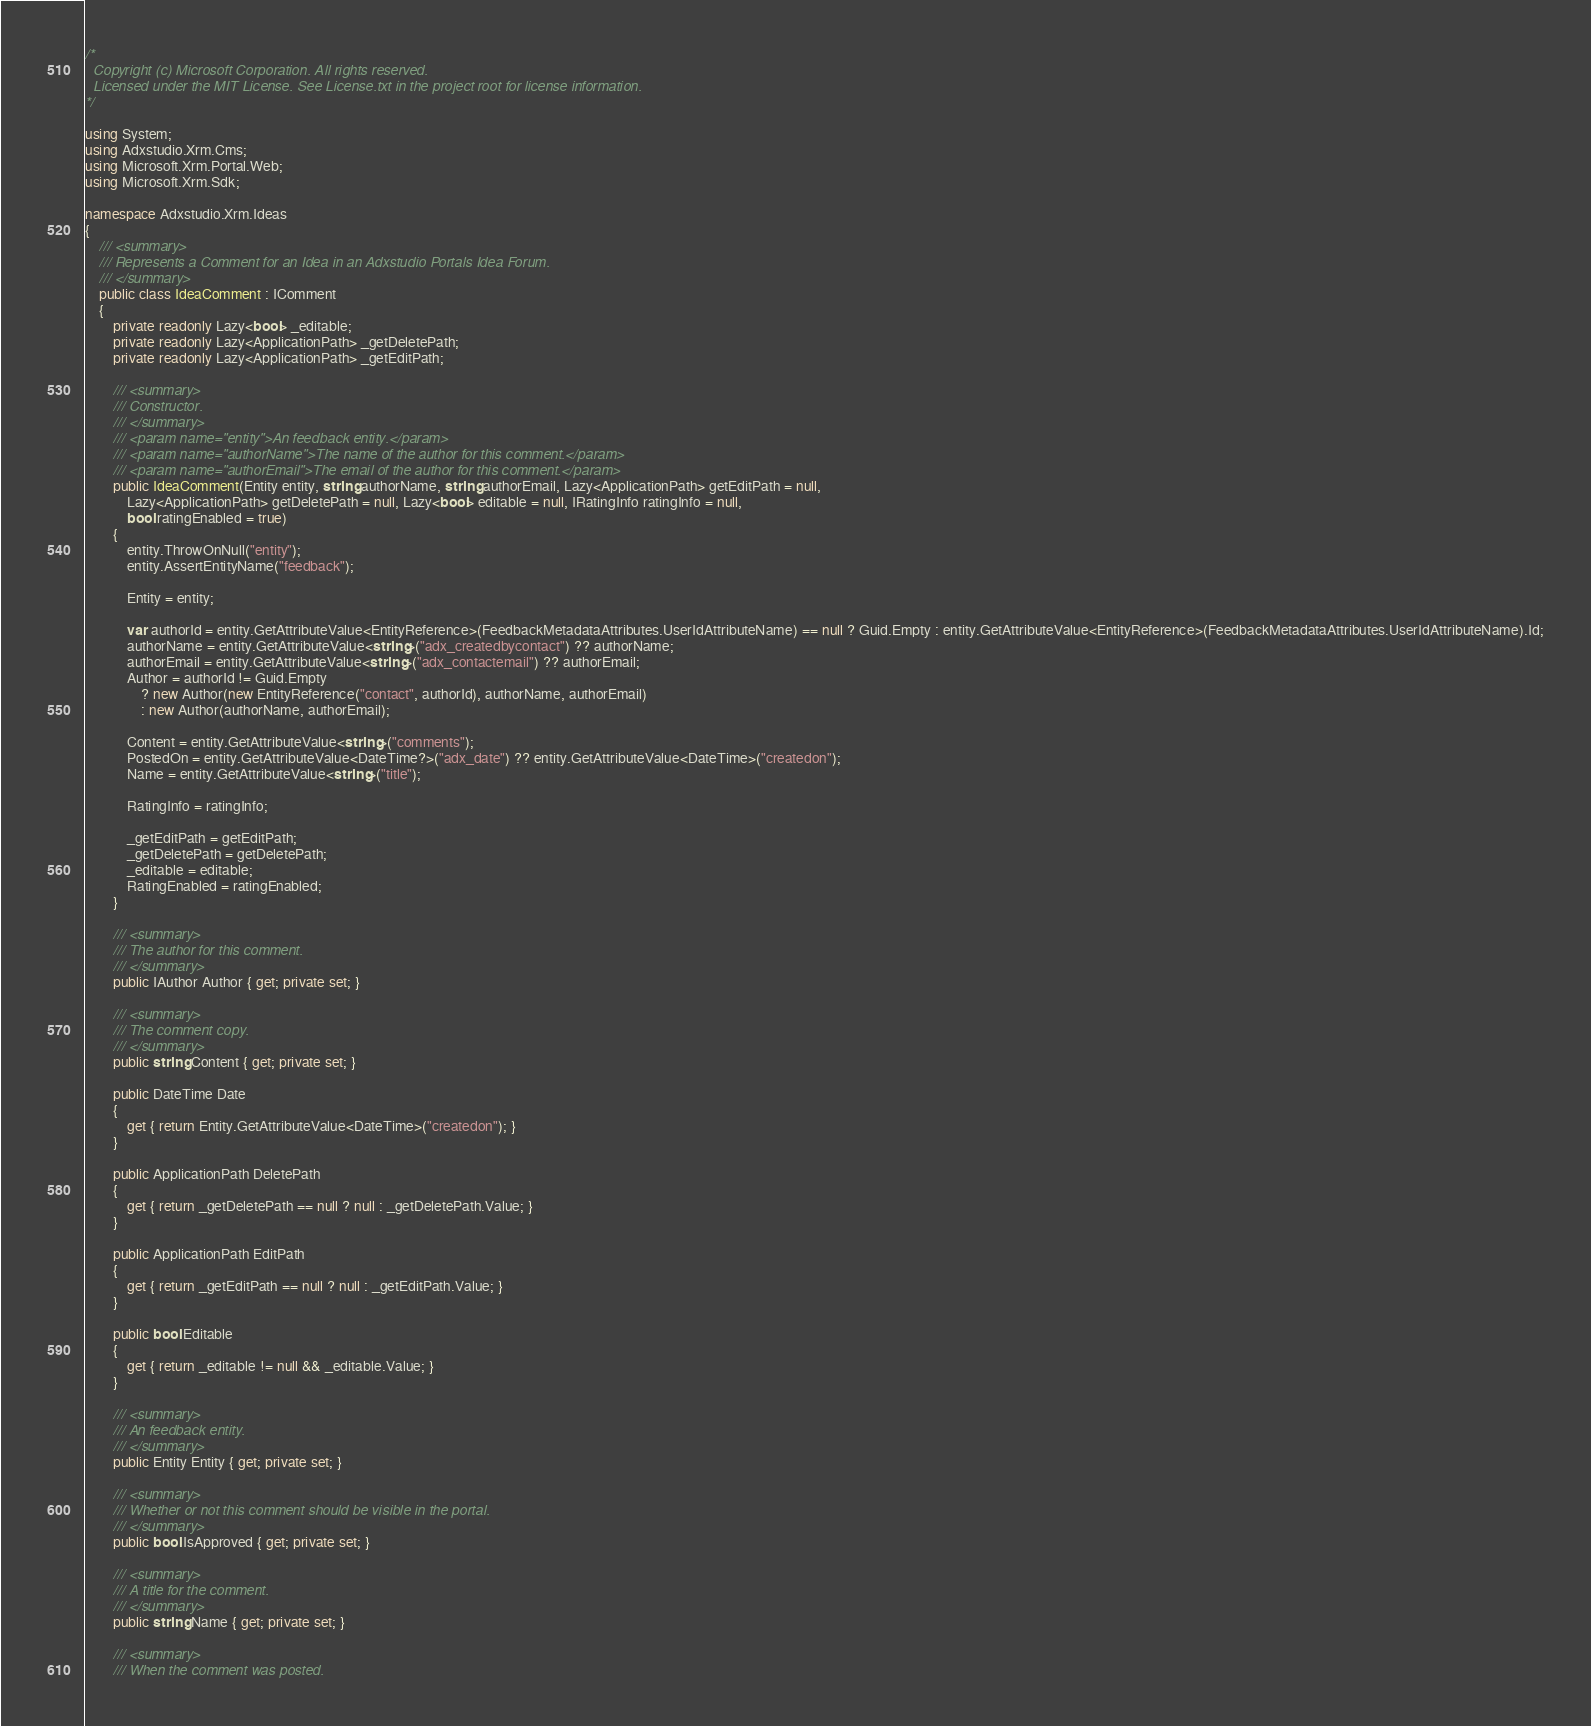<code> <loc_0><loc_0><loc_500><loc_500><_C#_>/*
  Copyright (c) Microsoft Corporation. All rights reserved.
  Licensed under the MIT License. See License.txt in the project root for license information.
*/

using System;
using Adxstudio.Xrm.Cms;
using Microsoft.Xrm.Portal.Web;
using Microsoft.Xrm.Sdk;

namespace Adxstudio.Xrm.Ideas
{
	/// <summary>
	/// Represents a Comment for an Idea in an Adxstudio Portals Idea Forum.
	/// </summary>
	public class IdeaComment : IComment
	{
		private readonly Lazy<bool> _editable;
		private readonly Lazy<ApplicationPath> _getDeletePath;
		private readonly Lazy<ApplicationPath> _getEditPath;

		/// <summary>
		/// Constructor.
		/// </summary>
		/// <param name="entity">An feedback entity.</param>
		/// <param name="authorName">The name of the author for this comment.</param>
		/// <param name="authorEmail">The email of the author for this comment.</param>
		public IdeaComment(Entity entity, string authorName, string authorEmail, Lazy<ApplicationPath> getEditPath = null,
			Lazy<ApplicationPath> getDeletePath = null, Lazy<bool> editable = null, IRatingInfo ratingInfo = null,
			bool ratingEnabled = true)
		{
			entity.ThrowOnNull("entity");
			entity.AssertEntityName("feedback");

			Entity = entity;

			var authorId = entity.GetAttributeValue<EntityReference>(FeedbackMetadataAttributes.UserIdAttributeName) == null ? Guid.Empty : entity.GetAttributeValue<EntityReference>(FeedbackMetadataAttributes.UserIdAttributeName).Id;
			authorName = entity.GetAttributeValue<string>("adx_createdbycontact") ?? authorName;
			authorEmail = entity.GetAttributeValue<string>("adx_contactemail") ?? authorEmail;
			Author = authorId != Guid.Empty
				? new Author(new EntityReference("contact", authorId), authorName, authorEmail)
				: new Author(authorName, authorEmail);

			Content = entity.GetAttributeValue<string>("comments");
			PostedOn = entity.GetAttributeValue<DateTime?>("adx_date") ?? entity.GetAttributeValue<DateTime>("createdon");
			Name = entity.GetAttributeValue<string>("title");

			RatingInfo = ratingInfo;

			_getEditPath = getEditPath;
			_getDeletePath = getDeletePath;
			_editable = editable;
			RatingEnabled = ratingEnabled;
		}

		/// <summary>
		/// The author for this comment.
		/// </summary>
		public IAuthor Author { get; private set; }

		/// <summary>
		/// The comment copy.
		/// </summary>
		public string Content { get; private set; }

		public DateTime Date
		{
			get { return Entity.GetAttributeValue<DateTime>("createdon"); }
		}

		public ApplicationPath DeletePath
		{
			get { return _getDeletePath == null ? null : _getDeletePath.Value; }
		}

		public ApplicationPath EditPath
		{
			get { return _getEditPath == null ? null : _getEditPath.Value; }
		}

		public bool Editable
		{
			get { return _editable != null && _editable.Value; }
		}

		/// <summary>
		/// An feedback entity.
		/// </summary>
		public Entity Entity { get; private set; }

		/// <summary>
		/// Whether or not this comment should be visible in the portal.
		/// </summary>
		public bool IsApproved { get; private set; }

		/// <summary>
		/// A title for the comment.
		/// </summary>
		public string Name { get; private set; }

		/// <summary>
		/// When the comment was posted.</code> 